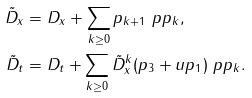Convert formula to latex. <formula><loc_0><loc_0><loc_500><loc_500>\tilde { D } _ { x } & = D _ { x } + \sum _ { k \geq 0 } p _ { k + 1 } \ p { p _ { k } } , \\ \tilde { D } _ { t } & = D _ { t } + \sum _ { k \geq 0 } \tilde { D } _ { x } ^ { k } ( p _ { 3 } + u p _ { 1 } ) \ p { p _ { k } } .</formula> 